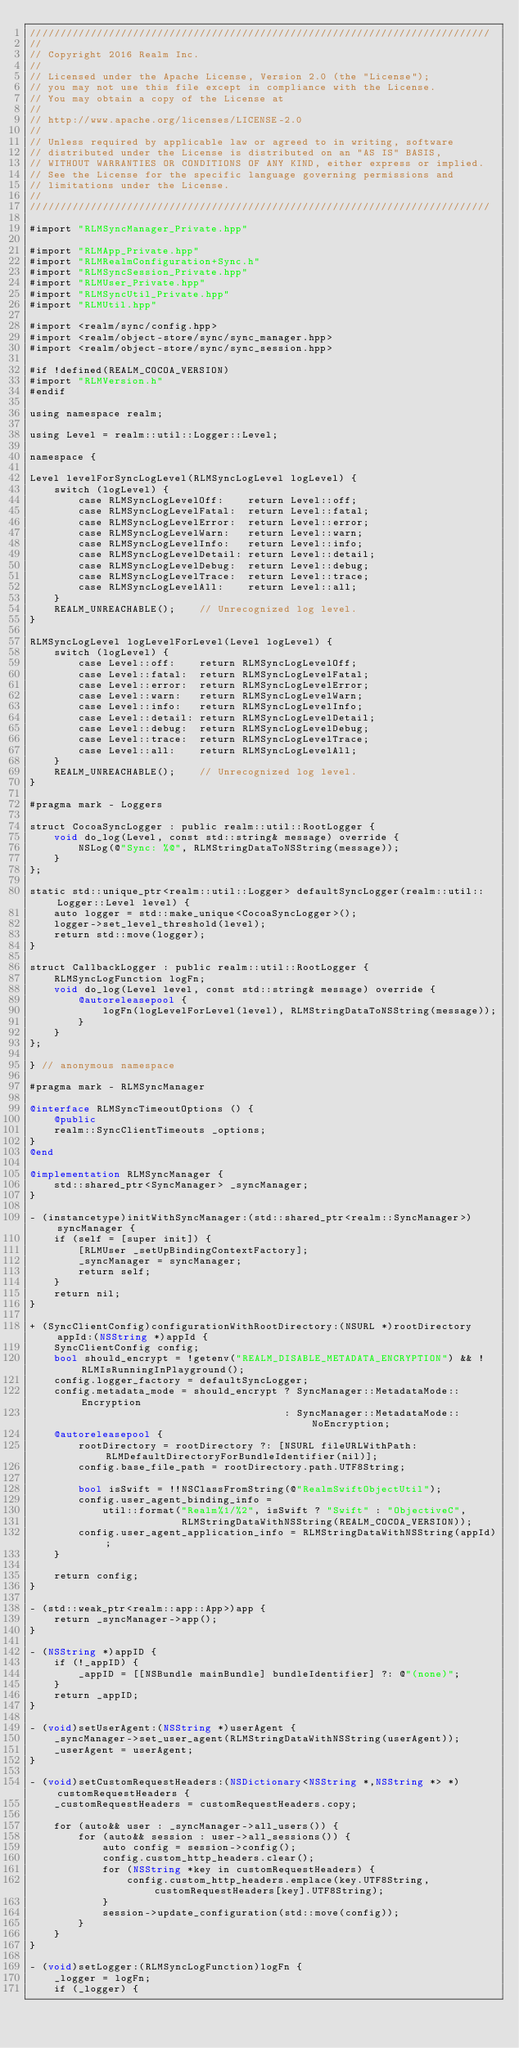<code> <loc_0><loc_0><loc_500><loc_500><_ObjectiveC_>////////////////////////////////////////////////////////////////////////////
//
// Copyright 2016 Realm Inc.
//
// Licensed under the Apache License, Version 2.0 (the "License");
// you may not use this file except in compliance with the License.
// You may obtain a copy of the License at
//
// http://www.apache.org/licenses/LICENSE-2.0
//
// Unless required by applicable law or agreed to in writing, software
// distributed under the License is distributed on an "AS IS" BASIS,
// WITHOUT WARRANTIES OR CONDITIONS OF ANY KIND, either express or implied.
// See the License for the specific language governing permissions and
// limitations under the License.
//
////////////////////////////////////////////////////////////////////////////

#import "RLMSyncManager_Private.hpp"

#import "RLMApp_Private.hpp"
#import "RLMRealmConfiguration+Sync.h"
#import "RLMSyncSession_Private.hpp"
#import "RLMUser_Private.hpp"
#import "RLMSyncUtil_Private.hpp"
#import "RLMUtil.hpp"

#import <realm/sync/config.hpp>
#import <realm/object-store/sync/sync_manager.hpp>
#import <realm/object-store/sync/sync_session.hpp>

#if !defined(REALM_COCOA_VERSION)
#import "RLMVersion.h"
#endif

using namespace realm;

using Level = realm::util::Logger::Level;

namespace {

Level levelForSyncLogLevel(RLMSyncLogLevel logLevel) {
    switch (logLevel) {
        case RLMSyncLogLevelOff:    return Level::off;
        case RLMSyncLogLevelFatal:  return Level::fatal;
        case RLMSyncLogLevelError:  return Level::error;
        case RLMSyncLogLevelWarn:   return Level::warn;
        case RLMSyncLogLevelInfo:   return Level::info;
        case RLMSyncLogLevelDetail: return Level::detail;
        case RLMSyncLogLevelDebug:  return Level::debug;
        case RLMSyncLogLevelTrace:  return Level::trace;
        case RLMSyncLogLevelAll:    return Level::all;
    }
    REALM_UNREACHABLE();    // Unrecognized log level.
}

RLMSyncLogLevel logLevelForLevel(Level logLevel) {
    switch (logLevel) {
        case Level::off:    return RLMSyncLogLevelOff;
        case Level::fatal:  return RLMSyncLogLevelFatal;
        case Level::error:  return RLMSyncLogLevelError;
        case Level::warn:   return RLMSyncLogLevelWarn;
        case Level::info:   return RLMSyncLogLevelInfo;
        case Level::detail: return RLMSyncLogLevelDetail;
        case Level::debug:  return RLMSyncLogLevelDebug;
        case Level::trace:  return RLMSyncLogLevelTrace;
        case Level::all:    return RLMSyncLogLevelAll;
    }
    REALM_UNREACHABLE();    // Unrecognized log level.
}

#pragma mark - Loggers

struct CocoaSyncLogger : public realm::util::RootLogger {
    void do_log(Level, const std::string& message) override {
        NSLog(@"Sync: %@", RLMStringDataToNSString(message));
    }
};

static std::unique_ptr<realm::util::Logger> defaultSyncLogger(realm::util::Logger::Level level) {
    auto logger = std::make_unique<CocoaSyncLogger>();
    logger->set_level_threshold(level);
    return std::move(logger);
}

struct CallbackLogger : public realm::util::RootLogger {
    RLMSyncLogFunction logFn;
    void do_log(Level level, const std::string& message) override {
        @autoreleasepool {
            logFn(logLevelForLevel(level), RLMStringDataToNSString(message));
        }
    }
};

} // anonymous namespace

#pragma mark - RLMSyncManager

@interface RLMSyncTimeoutOptions () {
    @public
    realm::SyncClientTimeouts _options;
}
@end

@implementation RLMSyncManager {
    std::shared_ptr<SyncManager> _syncManager;
}

- (instancetype)initWithSyncManager:(std::shared_ptr<realm::SyncManager>)syncManager {
    if (self = [super init]) {
        [RLMUser _setUpBindingContextFactory];
        _syncManager = syncManager;
        return self;
    }
    return nil;
}

+ (SyncClientConfig)configurationWithRootDirectory:(NSURL *)rootDirectory appId:(NSString *)appId {
    SyncClientConfig config;
    bool should_encrypt = !getenv("REALM_DISABLE_METADATA_ENCRYPTION") && !RLMIsRunningInPlayground();
    config.logger_factory = defaultSyncLogger;
    config.metadata_mode = should_encrypt ? SyncManager::MetadataMode::Encryption
                                          : SyncManager::MetadataMode::NoEncryption;
    @autoreleasepool {
        rootDirectory = rootDirectory ?: [NSURL fileURLWithPath:RLMDefaultDirectoryForBundleIdentifier(nil)];
        config.base_file_path = rootDirectory.path.UTF8String;

        bool isSwift = !!NSClassFromString(@"RealmSwiftObjectUtil");
        config.user_agent_binding_info =
            util::format("Realm%1/%2", isSwift ? "Swift" : "ObjectiveC",
                         RLMStringDataWithNSString(REALM_COCOA_VERSION));
        config.user_agent_application_info = RLMStringDataWithNSString(appId);
    }

    return config;
}

- (std::weak_ptr<realm::app::App>)app {
    return _syncManager->app();
}

- (NSString *)appID {
    if (!_appID) {
        _appID = [[NSBundle mainBundle] bundleIdentifier] ?: @"(none)";
    }
    return _appID;
}

- (void)setUserAgent:(NSString *)userAgent {
    _syncManager->set_user_agent(RLMStringDataWithNSString(userAgent));
    _userAgent = userAgent;
}

- (void)setCustomRequestHeaders:(NSDictionary<NSString *,NSString *> *)customRequestHeaders {
    _customRequestHeaders = customRequestHeaders.copy;

    for (auto&& user : _syncManager->all_users()) {
        for (auto&& session : user->all_sessions()) {
            auto config = session->config();
            config.custom_http_headers.clear();
            for (NSString *key in customRequestHeaders) {
                config.custom_http_headers.emplace(key.UTF8String, customRequestHeaders[key].UTF8String);
            }
            session->update_configuration(std::move(config));
        }
    }
}

- (void)setLogger:(RLMSyncLogFunction)logFn {
    _logger = logFn;
    if (_logger) {</code> 